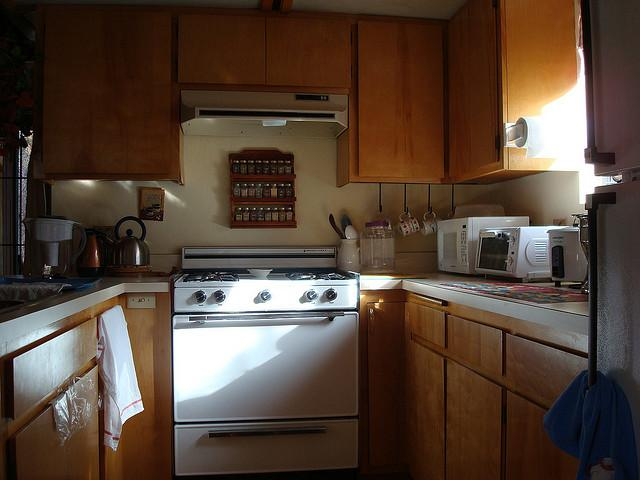What is the shorter rectangular appliance called? microwave 